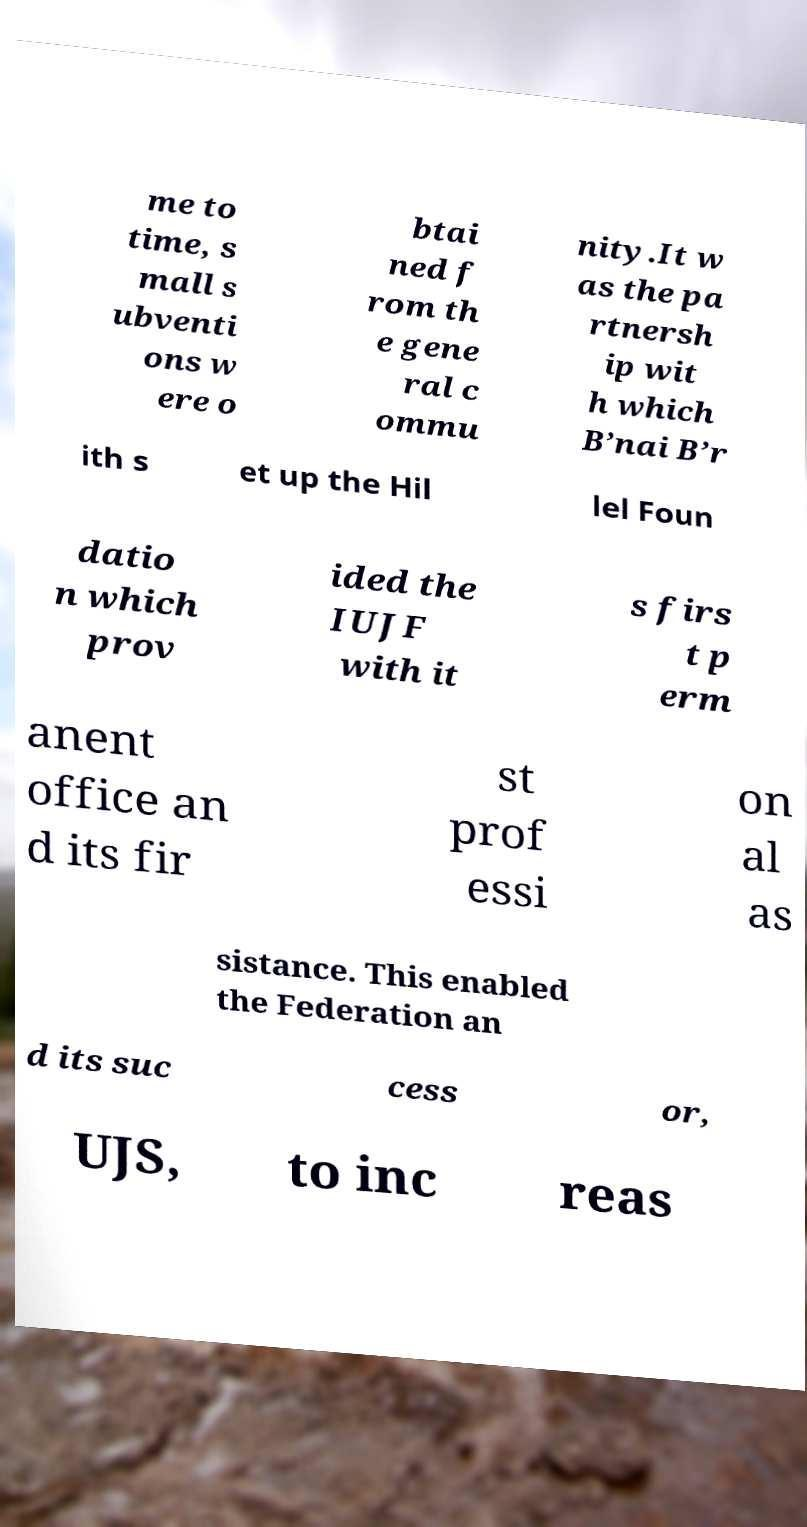Can you accurately transcribe the text from the provided image for me? me to time, s mall s ubventi ons w ere o btai ned f rom th e gene ral c ommu nity.It w as the pa rtnersh ip wit h which B’nai B’r ith s et up the Hil lel Foun datio n which prov ided the IUJF with it s firs t p erm anent office an d its fir st prof essi on al as sistance. This enabled the Federation an d its suc cess or, UJS, to inc reas 